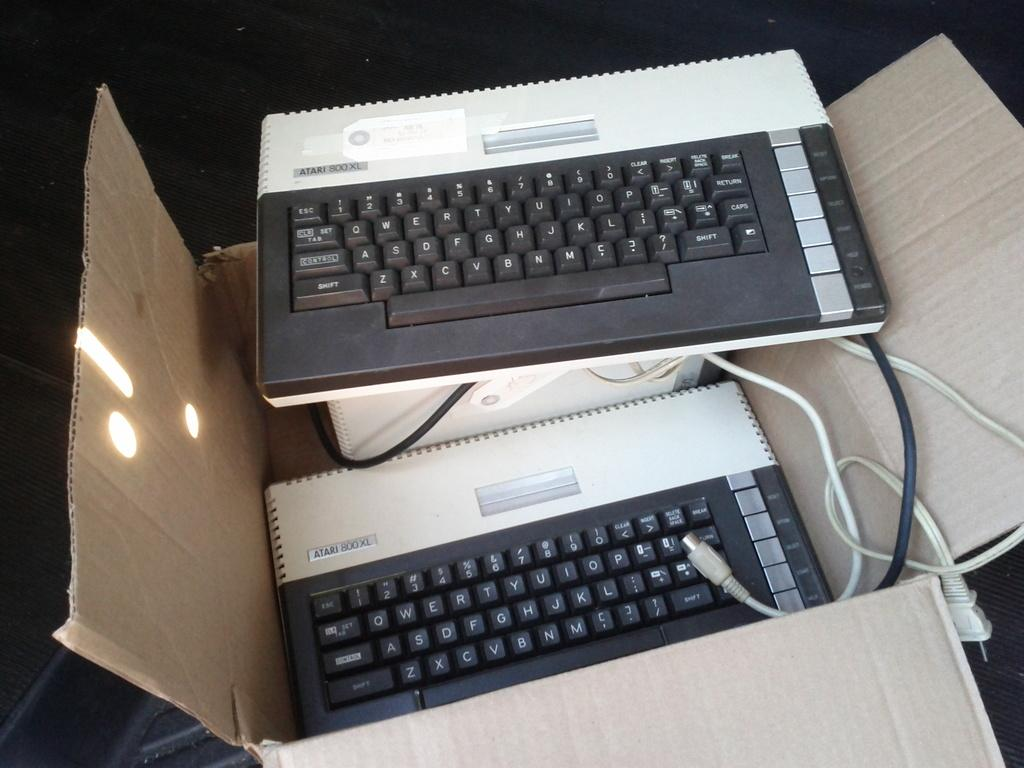<image>
Offer a succinct explanation of the picture presented. A box is opened with a few Atari 800 XL Keyboards in it. 